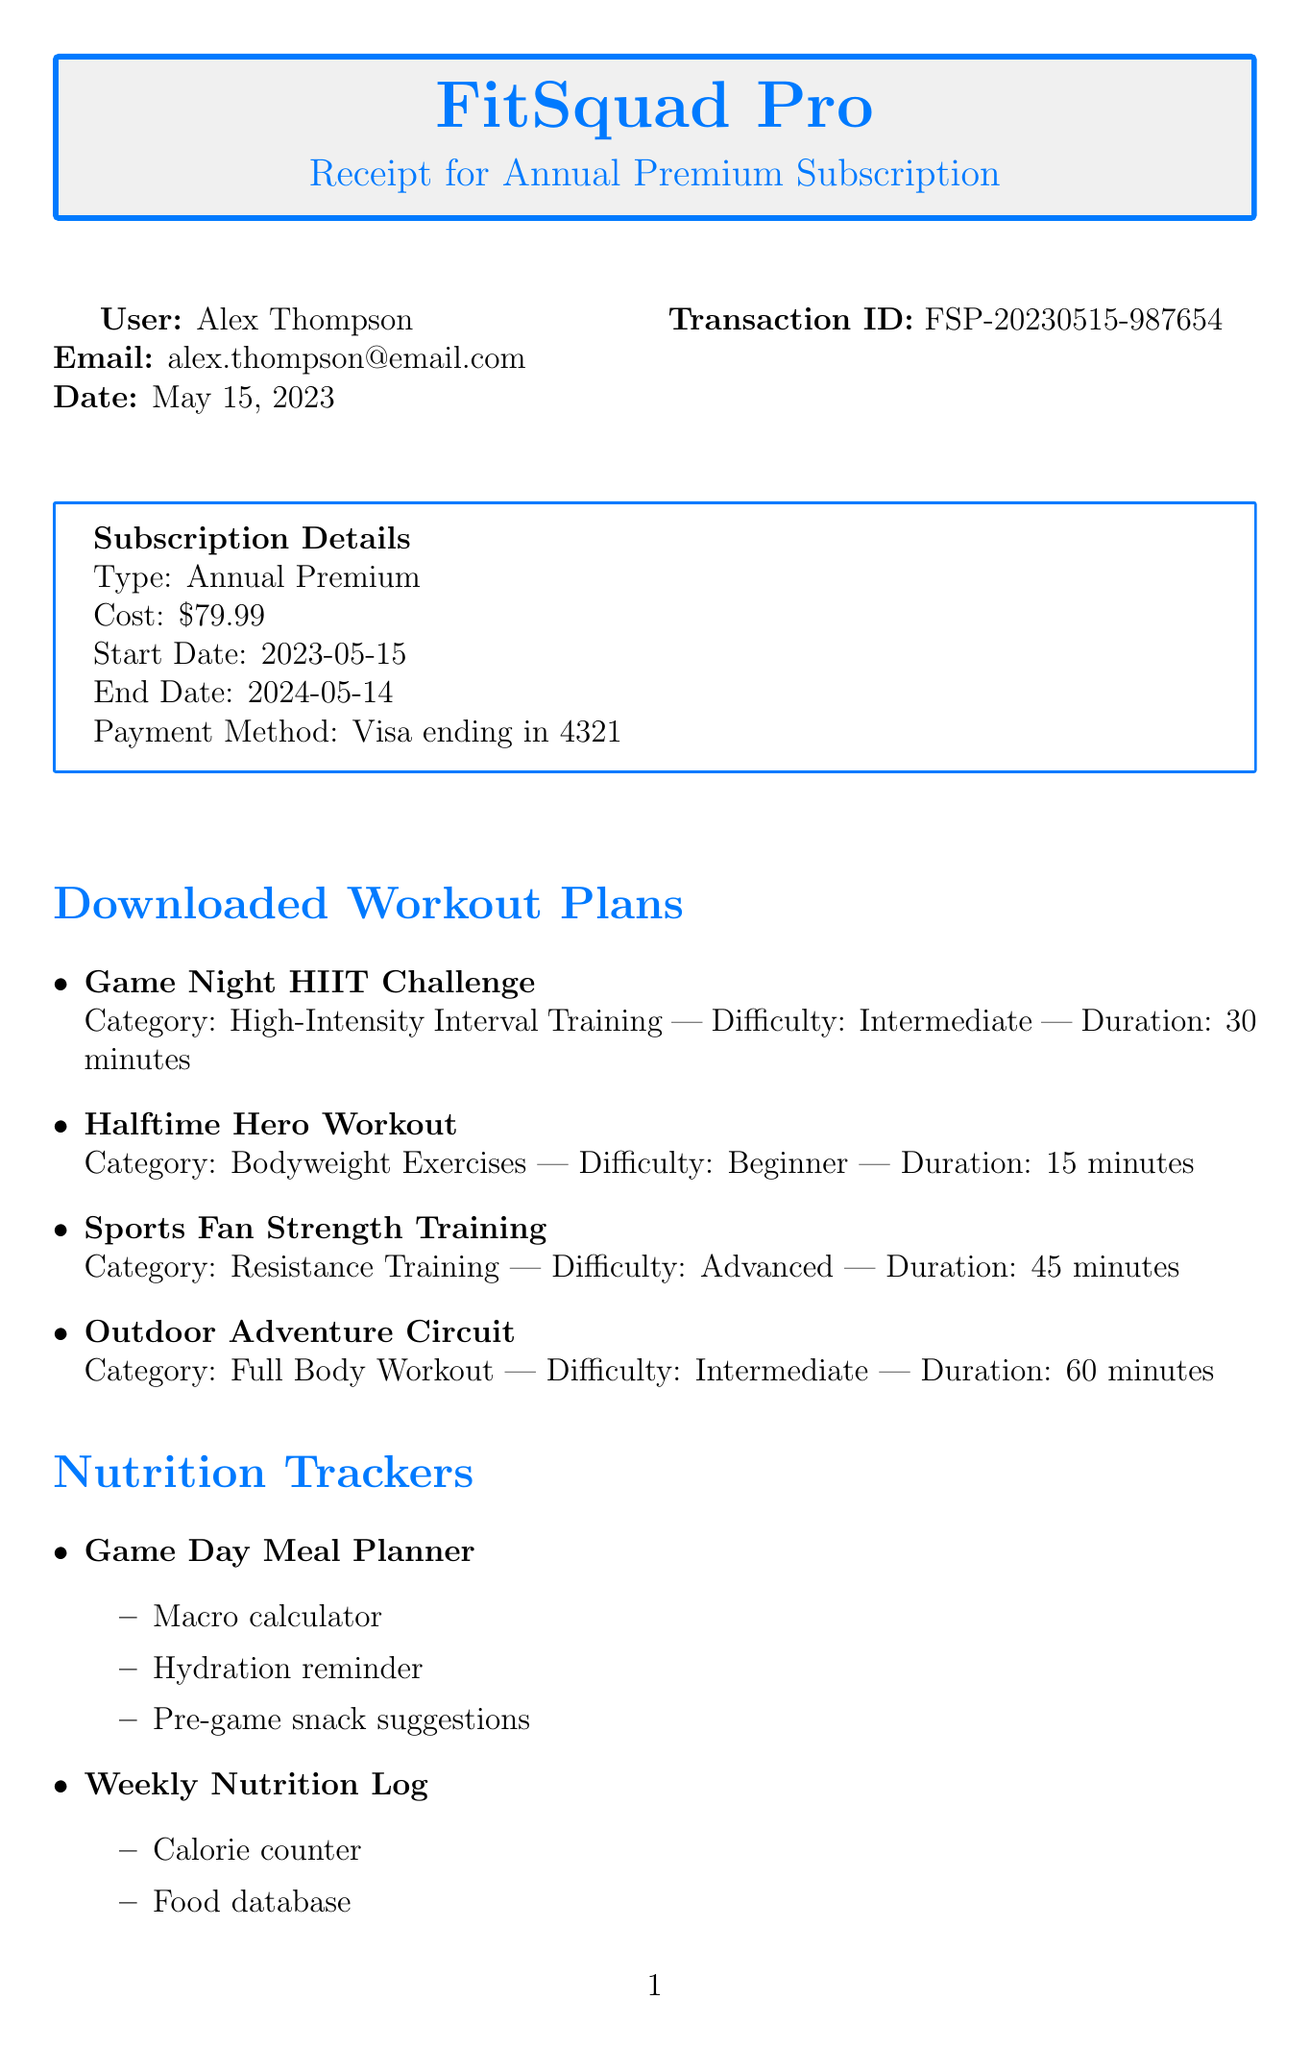What is the user's name? The user's name is clearly stated in the document under the user details section.
Answer: Alex Thompson What is the subscription cost? The subscription cost is indicated in the subscription details section of the document.
Answer: $79.99 When does the subscription end? The subscription end date is specified in the subscription details section.
Answer: 2024-05-14 What is one feature of the "Game Day Meal Planner"? One feature of this tracker is listed in the nutrition trackers section of the document.
Answer: Macro calculator How long is the "Halftime Hero Workout"? The duration of this workout plan is provided in the downloaded workout plans section.
Answer: 15 minutes What payment method was used? The payment method is mentioned in the subscription details section.
Answer: Visa ending in 4321 What type of fitness tracking feature is included? This is noted in the additional features section of the document.
Answer: Integration with Apple Health and Google Fit How many downloaded workout plans are listed? The number of workout plans can be counted in the downloaded workout plans section.
Answer: 4 Which category does "Sports Fan Strength Training" fall under? The category for this workout plan is specified in the downloaded workout plans section.
Answer: Resistance Training 